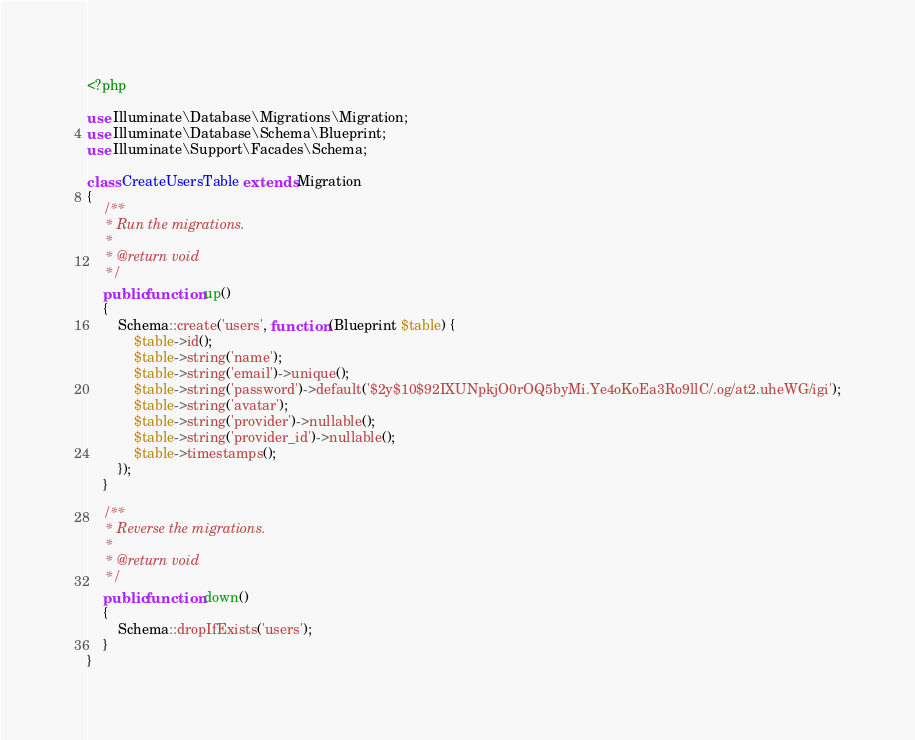Convert code to text. <code><loc_0><loc_0><loc_500><loc_500><_PHP_><?php

use Illuminate\Database\Migrations\Migration;
use Illuminate\Database\Schema\Blueprint;
use Illuminate\Support\Facades\Schema;

class CreateUsersTable extends Migration
{
    /**
     * Run the migrations.
     *
     * @return void
     */
    public function up()
    {
        Schema::create('users', function (Blueprint $table) {
            $table->id();
            $table->string('name');
            $table->string('email')->unique();
            $table->string('password')->default('$2y$10$92IXUNpkjO0rOQ5byMi.Ye4oKoEa3Ro9llC/.og/at2.uheWG/igi');
            $table->string('avatar');
            $table->string('provider')->nullable();
            $table->string('provider_id')->nullable();
            $table->timestamps();
        });
    }

    /**
     * Reverse the migrations.
     *
     * @return void
     */
    public function down()
    {
        Schema::dropIfExists('users');
    }
}
</code> 